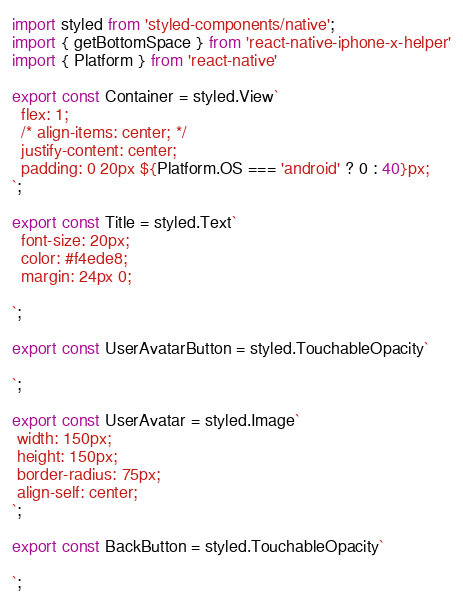Convert code to text. <code><loc_0><loc_0><loc_500><loc_500><_TypeScript_>import styled from 'styled-components/native';
import { getBottomSpace } from 'react-native-iphone-x-helper'
import { Platform } from 'react-native'

export const Container = styled.View`
  flex: 1;
  /* align-items: center; */
  justify-content: center;
  padding: 0 20px ${Platform.OS === 'android' ? 0 : 40}px;
`;

export const Title = styled.Text`
  font-size: 20px;
  color: #f4ede8;
  margin: 24px 0;

`;

export const UserAvatarButton = styled.TouchableOpacity`

`;

export const UserAvatar = styled.Image`
 width: 150px;
 height: 150px;
 border-radius: 75px;
 align-self: center;
`;

export const BackButton = styled.TouchableOpacity`

`;
</code> 